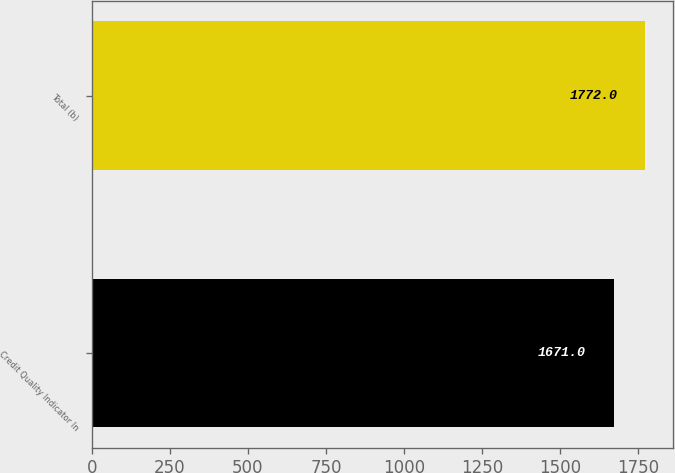Convert chart. <chart><loc_0><loc_0><loc_500><loc_500><bar_chart><fcel>Credit Quality Indicator In<fcel>Total (b)<nl><fcel>1671<fcel>1772<nl></chart> 